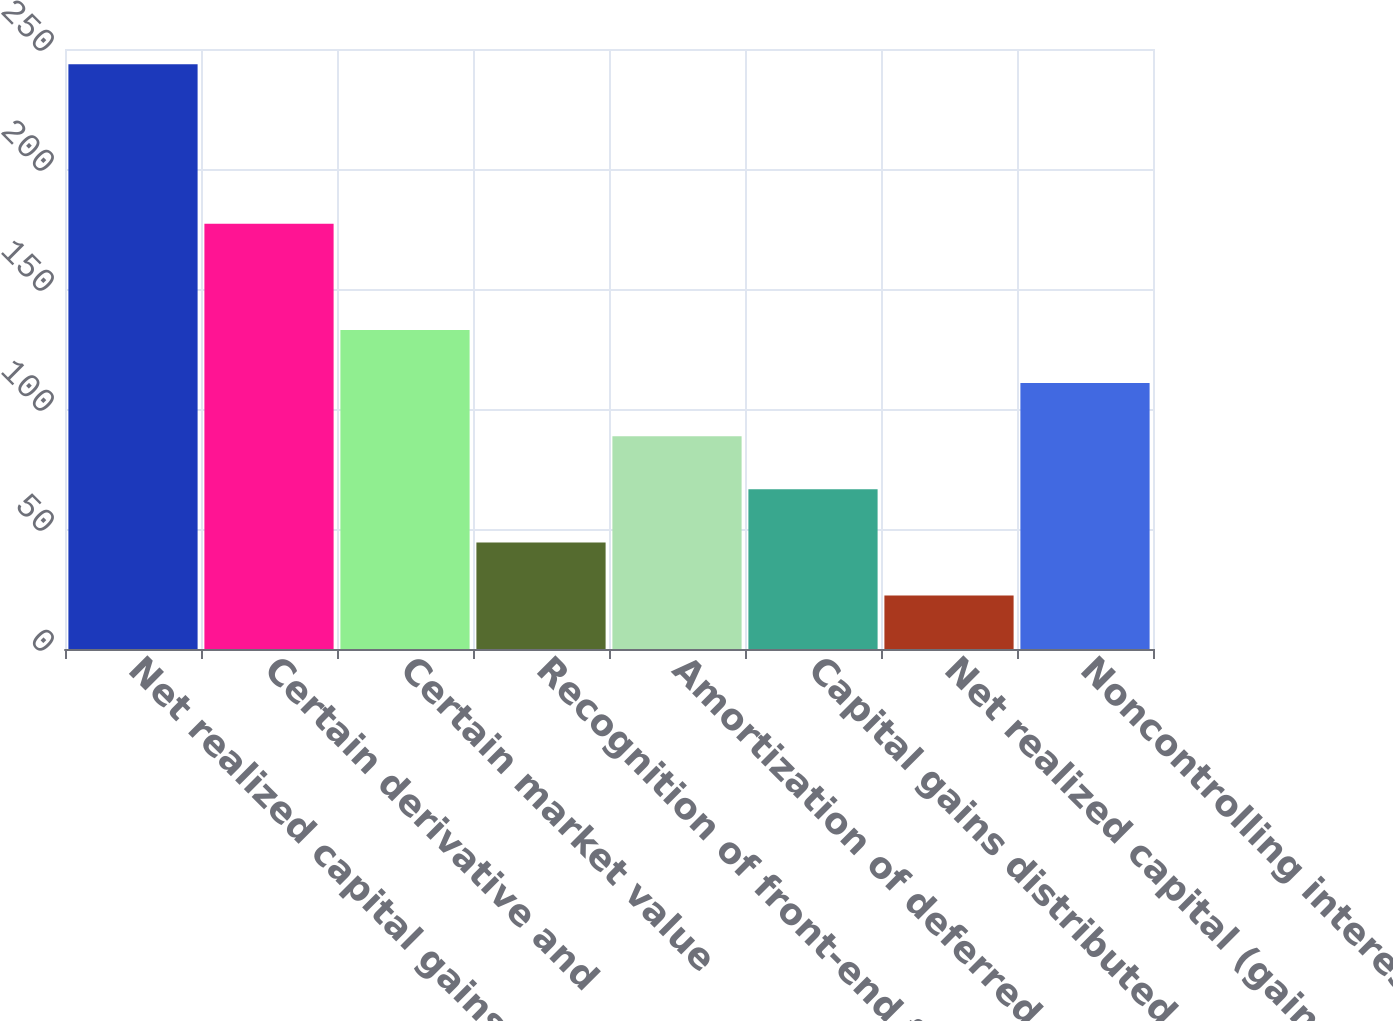Convert chart to OTSL. <chart><loc_0><loc_0><loc_500><loc_500><bar_chart><fcel>Net realized capital gains<fcel>Certain derivative and<fcel>Certain market value<fcel>Recognition of front-end fee<fcel>Amortization of deferred<fcel>Capital gains distributed<fcel>Net realized capital (gains)<fcel>Noncontrolling interest<nl><fcel>243.64<fcel>177.22<fcel>132.94<fcel>44.38<fcel>88.66<fcel>66.52<fcel>22.24<fcel>110.8<nl></chart> 